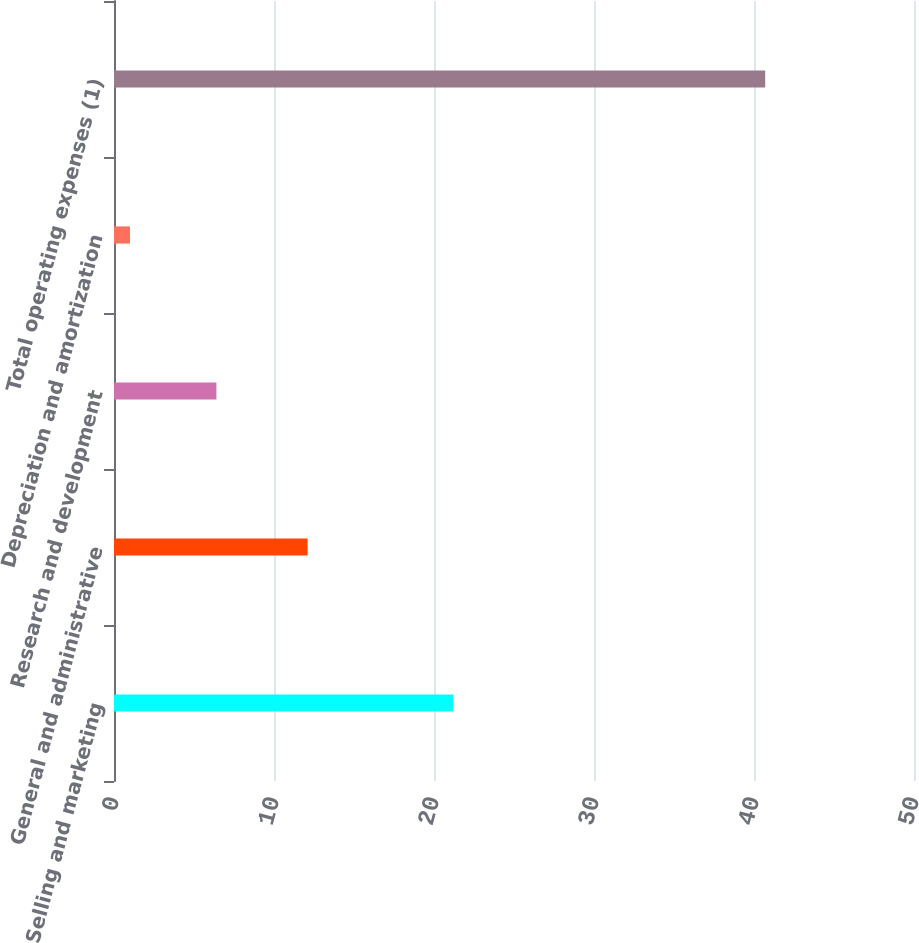<chart> <loc_0><loc_0><loc_500><loc_500><bar_chart><fcel>Selling and marketing<fcel>General and administrative<fcel>Research and development<fcel>Depreciation and amortization<fcel>Total operating expenses (1)<nl><fcel>21.2<fcel>12.1<fcel>6.4<fcel>1<fcel>40.7<nl></chart> 